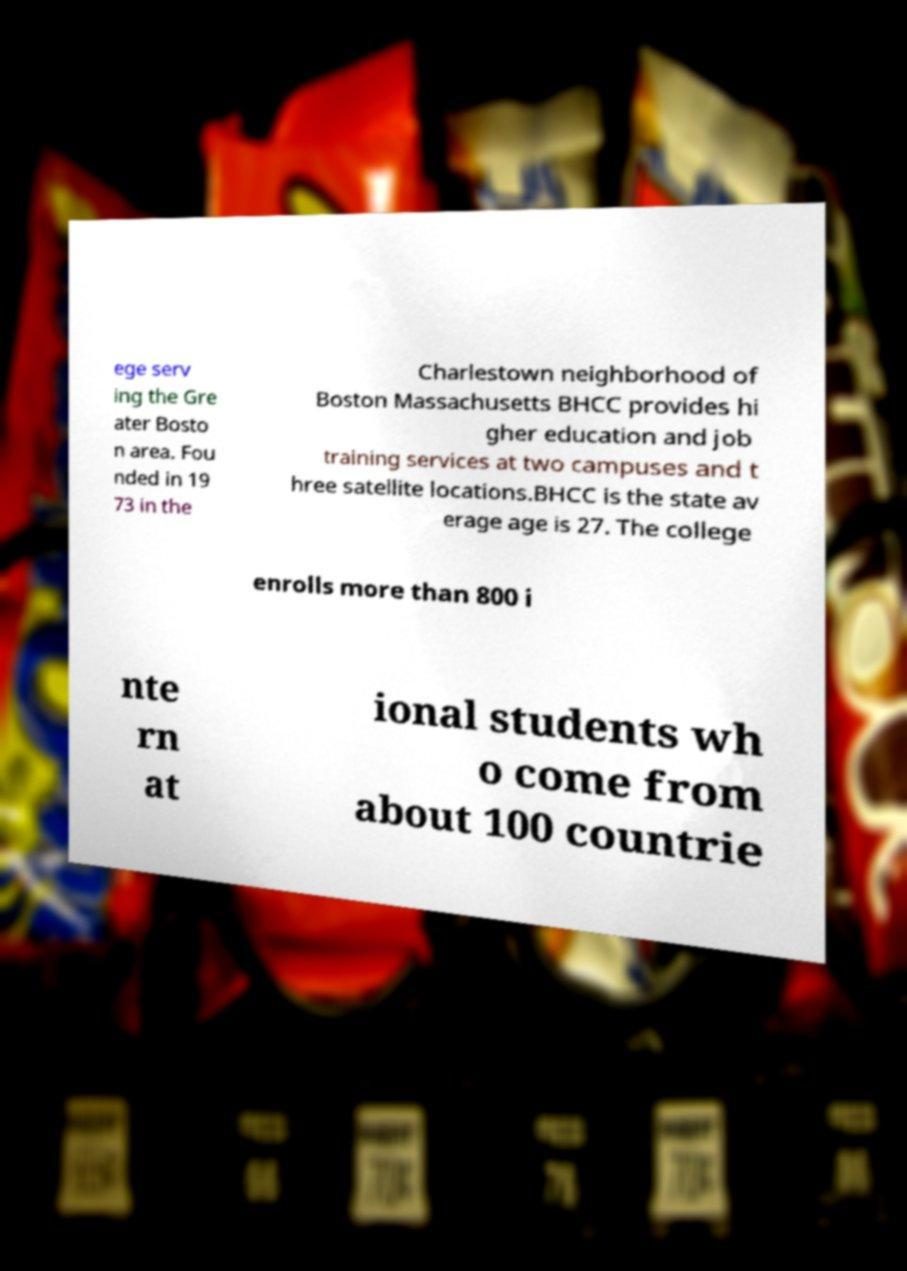Can you read and provide the text displayed in the image?This photo seems to have some interesting text. Can you extract and type it out for me? ege serv ing the Gre ater Bosto n area. Fou nded in 19 73 in the Charlestown neighborhood of Boston Massachusetts BHCC provides hi gher education and job training services at two campuses and t hree satellite locations.BHCC is the state av erage age is 27. The college enrolls more than 800 i nte rn at ional students wh o come from about 100 countrie 